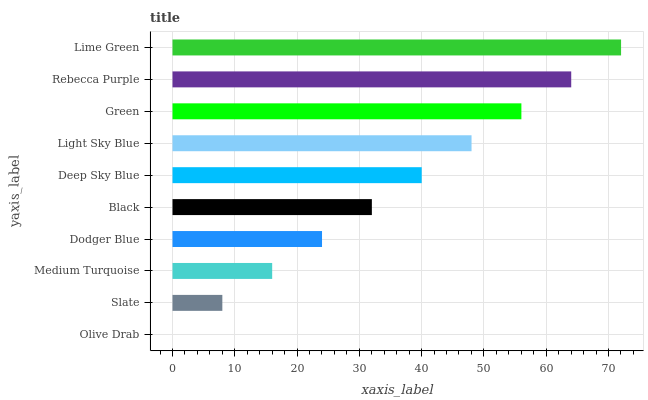Is Olive Drab the minimum?
Answer yes or no. Yes. Is Lime Green the maximum?
Answer yes or no. Yes. Is Slate the minimum?
Answer yes or no. No. Is Slate the maximum?
Answer yes or no. No. Is Slate greater than Olive Drab?
Answer yes or no. Yes. Is Olive Drab less than Slate?
Answer yes or no. Yes. Is Olive Drab greater than Slate?
Answer yes or no. No. Is Slate less than Olive Drab?
Answer yes or no. No. Is Deep Sky Blue the high median?
Answer yes or no. Yes. Is Black the low median?
Answer yes or no. Yes. Is Black the high median?
Answer yes or no. No. Is Lime Green the low median?
Answer yes or no. No. 